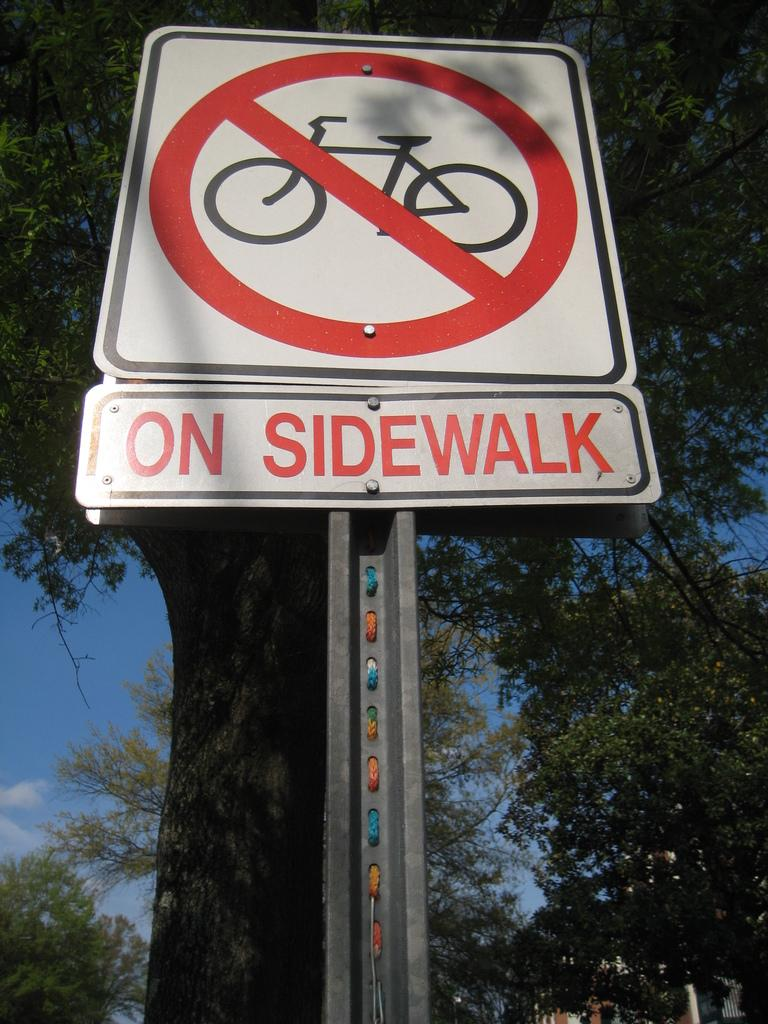<image>
Describe the image concisely. A sign shows no bikes allowed on the sidewalk. 